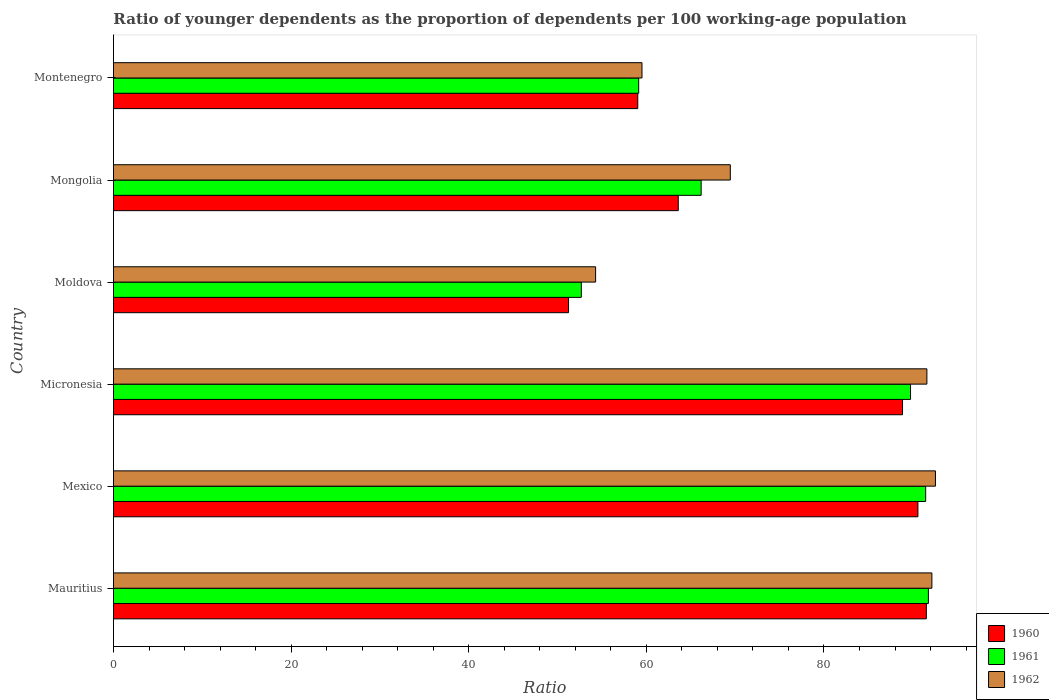How many groups of bars are there?
Give a very brief answer. 6. How many bars are there on the 4th tick from the top?
Offer a very short reply. 3. How many bars are there on the 3rd tick from the bottom?
Your answer should be very brief. 3. What is the label of the 2nd group of bars from the top?
Offer a terse response. Mongolia. In how many cases, is the number of bars for a given country not equal to the number of legend labels?
Offer a terse response. 0. What is the age dependency ratio(young) in 1960 in Montenegro?
Your response must be concise. 59.03. Across all countries, what is the maximum age dependency ratio(young) in 1962?
Provide a short and direct response. 92.55. Across all countries, what is the minimum age dependency ratio(young) in 1960?
Provide a succinct answer. 51.24. In which country was the age dependency ratio(young) in 1961 maximum?
Provide a succinct answer. Mauritius. In which country was the age dependency ratio(young) in 1961 minimum?
Offer a very short reply. Moldova. What is the total age dependency ratio(young) in 1960 in the graph?
Your response must be concise. 444.82. What is the difference between the age dependency ratio(young) in 1961 in Mongolia and that in Montenegro?
Your answer should be very brief. 7.03. What is the difference between the age dependency ratio(young) in 1962 in Mauritius and the age dependency ratio(young) in 1961 in Mexico?
Give a very brief answer. 0.7. What is the average age dependency ratio(young) in 1961 per country?
Your answer should be very brief. 75.16. What is the difference between the age dependency ratio(young) in 1961 and age dependency ratio(young) in 1960 in Mongolia?
Your answer should be very brief. 2.58. In how many countries, is the age dependency ratio(young) in 1962 greater than 24 ?
Offer a terse response. 6. What is the ratio of the age dependency ratio(young) in 1960 in Mauritius to that in Micronesia?
Your answer should be very brief. 1.03. Is the difference between the age dependency ratio(young) in 1961 in Mauritius and Montenegro greater than the difference between the age dependency ratio(young) in 1960 in Mauritius and Montenegro?
Make the answer very short. Yes. What is the difference between the highest and the second highest age dependency ratio(young) in 1960?
Keep it short and to the point. 0.95. What is the difference between the highest and the lowest age dependency ratio(young) in 1960?
Make the answer very short. 40.29. In how many countries, is the age dependency ratio(young) in 1961 greater than the average age dependency ratio(young) in 1961 taken over all countries?
Offer a very short reply. 3. Is the sum of the age dependency ratio(young) in 1960 in Mexico and Montenegro greater than the maximum age dependency ratio(young) in 1962 across all countries?
Offer a very short reply. Yes. What does the 2nd bar from the top in Micronesia represents?
Give a very brief answer. 1961. Is it the case that in every country, the sum of the age dependency ratio(young) in 1962 and age dependency ratio(young) in 1961 is greater than the age dependency ratio(young) in 1960?
Make the answer very short. Yes. Are all the bars in the graph horizontal?
Your answer should be very brief. Yes. What is the difference between two consecutive major ticks on the X-axis?
Offer a very short reply. 20. Are the values on the major ticks of X-axis written in scientific E-notation?
Your answer should be compact. No. Does the graph contain any zero values?
Your answer should be compact. No. How are the legend labels stacked?
Your response must be concise. Vertical. What is the title of the graph?
Keep it short and to the point. Ratio of younger dependents as the proportion of dependents per 100 working-age population. Does "1979" appear as one of the legend labels in the graph?
Give a very brief answer. No. What is the label or title of the X-axis?
Ensure brevity in your answer.  Ratio. What is the Ratio in 1960 in Mauritius?
Provide a short and direct response. 91.53. What is the Ratio in 1961 in Mauritius?
Make the answer very short. 91.76. What is the Ratio of 1962 in Mauritius?
Provide a short and direct response. 92.15. What is the Ratio in 1960 in Mexico?
Give a very brief answer. 90.58. What is the Ratio in 1961 in Mexico?
Offer a terse response. 91.45. What is the Ratio of 1962 in Mexico?
Your response must be concise. 92.55. What is the Ratio in 1960 in Micronesia?
Provide a succinct answer. 88.85. What is the Ratio of 1961 in Micronesia?
Your answer should be compact. 89.75. What is the Ratio in 1962 in Micronesia?
Offer a terse response. 91.59. What is the Ratio of 1960 in Moldova?
Give a very brief answer. 51.24. What is the Ratio in 1961 in Moldova?
Give a very brief answer. 52.68. What is the Ratio in 1962 in Moldova?
Provide a succinct answer. 54.29. What is the Ratio in 1960 in Mongolia?
Provide a succinct answer. 63.59. What is the Ratio of 1961 in Mongolia?
Your response must be concise. 66.17. What is the Ratio of 1962 in Mongolia?
Make the answer very short. 69.46. What is the Ratio of 1960 in Montenegro?
Provide a short and direct response. 59.03. What is the Ratio in 1961 in Montenegro?
Keep it short and to the point. 59.14. What is the Ratio in 1962 in Montenegro?
Make the answer very short. 59.51. Across all countries, what is the maximum Ratio in 1960?
Provide a succinct answer. 91.53. Across all countries, what is the maximum Ratio in 1961?
Provide a short and direct response. 91.76. Across all countries, what is the maximum Ratio of 1962?
Your answer should be compact. 92.55. Across all countries, what is the minimum Ratio of 1960?
Provide a succinct answer. 51.24. Across all countries, what is the minimum Ratio in 1961?
Ensure brevity in your answer.  52.68. Across all countries, what is the minimum Ratio in 1962?
Offer a very short reply. 54.29. What is the total Ratio of 1960 in the graph?
Give a very brief answer. 444.82. What is the total Ratio in 1961 in the graph?
Offer a very short reply. 450.94. What is the total Ratio in 1962 in the graph?
Your answer should be very brief. 459.55. What is the difference between the Ratio of 1960 in Mauritius and that in Mexico?
Your answer should be very brief. 0.95. What is the difference between the Ratio of 1961 in Mauritius and that in Mexico?
Give a very brief answer. 0.31. What is the difference between the Ratio of 1962 in Mauritius and that in Mexico?
Make the answer very short. -0.4. What is the difference between the Ratio in 1960 in Mauritius and that in Micronesia?
Your response must be concise. 2.68. What is the difference between the Ratio of 1961 in Mauritius and that in Micronesia?
Ensure brevity in your answer.  2.01. What is the difference between the Ratio in 1962 in Mauritius and that in Micronesia?
Ensure brevity in your answer.  0.56. What is the difference between the Ratio of 1960 in Mauritius and that in Moldova?
Ensure brevity in your answer.  40.29. What is the difference between the Ratio of 1961 in Mauritius and that in Moldova?
Give a very brief answer. 39.08. What is the difference between the Ratio in 1962 in Mauritius and that in Moldova?
Your response must be concise. 37.86. What is the difference between the Ratio in 1960 in Mauritius and that in Mongolia?
Provide a succinct answer. 27.93. What is the difference between the Ratio of 1961 in Mauritius and that in Mongolia?
Offer a terse response. 25.59. What is the difference between the Ratio in 1962 in Mauritius and that in Mongolia?
Offer a very short reply. 22.7. What is the difference between the Ratio in 1960 in Mauritius and that in Montenegro?
Offer a terse response. 32.49. What is the difference between the Ratio in 1961 in Mauritius and that in Montenegro?
Your answer should be very brief. 32.62. What is the difference between the Ratio of 1962 in Mauritius and that in Montenegro?
Your answer should be very brief. 32.64. What is the difference between the Ratio in 1960 in Mexico and that in Micronesia?
Provide a short and direct response. 1.73. What is the difference between the Ratio of 1961 in Mexico and that in Micronesia?
Make the answer very short. 1.7. What is the difference between the Ratio in 1962 in Mexico and that in Micronesia?
Ensure brevity in your answer.  0.97. What is the difference between the Ratio of 1960 in Mexico and that in Moldova?
Give a very brief answer. 39.34. What is the difference between the Ratio in 1961 in Mexico and that in Moldova?
Provide a short and direct response. 38.77. What is the difference between the Ratio of 1962 in Mexico and that in Moldova?
Offer a very short reply. 38.27. What is the difference between the Ratio of 1960 in Mexico and that in Mongolia?
Make the answer very short. 26.99. What is the difference between the Ratio of 1961 in Mexico and that in Mongolia?
Give a very brief answer. 25.28. What is the difference between the Ratio in 1962 in Mexico and that in Mongolia?
Ensure brevity in your answer.  23.1. What is the difference between the Ratio in 1960 in Mexico and that in Montenegro?
Provide a succinct answer. 31.55. What is the difference between the Ratio in 1961 in Mexico and that in Montenegro?
Offer a terse response. 32.31. What is the difference between the Ratio in 1962 in Mexico and that in Montenegro?
Provide a succinct answer. 33.04. What is the difference between the Ratio in 1960 in Micronesia and that in Moldova?
Keep it short and to the point. 37.61. What is the difference between the Ratio of 1961 in Micronesia and that in Moldova?
Provide a succinct answer. 37.07. What is the difference between the Ratio in 1962 in Micronesia and that in Moldova?
Make the answer very short. 37.3. What is the difference between the Ratio in 1960 in Micronesia and that in Mongolia?
Your answer should be compact. 25.25. What is the difference between the Ratio in 1961 in Micronesia and that in Mongolia?
Provide a succinct answer. 23.58. What is the difference between the Ratio in 1962 in Micronesia and that in Mongolia?
Give a very brief answer. 22.13. What is the difference between the Ratio in 1960 in Micronesia and that in Montenegro?
Offer a terse response. 29.81. What is the difference between the Ratio of 1961 in Micronesia and that in Montenegro?
Provide a succinct answer. 30.61. What is the difference between the Ratio in 1962 in Micronesia and that in Montenegro?
Your answer should be very brief. 32.08. What is the difference between the Ratio of 1960 in Moldova and that in Mongolia?
Offer a very short reply. -12.36. What is the difference between the Ratio in 1961 in Moldova and that in Mongolia?
Provide a short and direct response. -13.49. What is the difference between the Ratio in 1962 in Moldova and that in Mongolia?
Offer a terse response. -15.17. What is the difference between the Ratio of 1960 in Moldova and that in Montenegro?
Give a very brief answer. -7.79. What is the difference between the Ratio in 1961 in Moldova and that in Montenegro?
Your answer should be compact. -6.46. What is the difference between the Ratio in 1962 in Moldova and that in Montenegro?
Your answer should be very brief. -5.22. What is the difference between the Ratio in 1960 in Mongolia and that in Montenegro?
Ensure brevity in your answer.  4.56. What is the difference between the Ratio of 1961 in Mongolia and that in Montenegro?
Give a very brief answer. 7.03. What is the difference between the Ratio in 1962 in Mongolia and that in Montenegro?
Ensure brevity in your answer.  9.95. What is the difference between the Ratio in 1960 in Mauritius and the Ratio in 1961 in Mexico?
Your answer should be very brief. 0.08. What is the difference between the Ratio of 1960 in Mauritius and the Ratio of 1962 in Mexico?
Your response must be concise. -1.03. What is the difference between the Ratio of 1961 in Mauritius and the Ratio of 1962 in Mexico?
Offer a terse response. -0.8. What is the difference between the Ratio of 1960 in Mauritius and the Ratio of 1961 in Micronesia?
Keep it short and to the point. 1.78. What is the difference between the Ratio of 1960 in Mauritius and the Ratio of 1962 in Micronesia?
Give a very brief answer. -0.06. What is the difference between the Ratio in 1961 in Mauritius and the Ratio in 1962 in Micronesia?
Give a very brief answer. 0.17. What is the difference between the Ratio of 1960 in Mauritius and the Ratio of 1961 in Moldova?
Make the answer very short. 38.85. What is the difference between the Ratio in 1960 in Mauritius and the Ratio in 1962 in Moldova?
Your answer should be compact. 37.24. What is the difference between the Ratio of 1961 in Mauritius and the Ratio of 1962 in Moldova?
Offer a very short reply. 37.47. What is the difference between the Ratio in 1960 in Mauritius and the Ratio in 1961 in Mongolia?
Your answer should be very brief. 25.36. What is the difference between the Ratio in 1960 in Mauritius and the Ratio in 1962 in Mongolia?
Provide a succinct answer. 22.07. What is the difference between the Ratio of 1961 in Mauritius and the Ratio of 1962 in Mongolia?
Provide a succinct answer. 22.3. What is the difference between the Ratio in 1960 in Mauritius and the Ratio in 1961 in Montenegro?
Ensure brevity in your answer.  32.39. What is the difference between the Ratio of 1960 in Mauritius and the Ratio of 1962 in Montenegro?
Make the answer very short. 32.02. What is the difference between the Ratio of 1961 in Mauritius and the Ratio of 1962 in Montenegro?
Your answer should be compact. 32.25. What is the difference between the Ratio of 1960 in Mexico and the Ratio of 1961 in Micronesia?
Ensure brevity in your answer.  0.83. What is the difference between the Ratio of 1960 in Mexico and the Ratio of 1962 in Micronesia?
Give a very brief answer. -1.01. What is the difference between the Ratio of 1961 in Mexico and the Ratio of 1962 in Micronesia?
Keep it short and to the point. -0.14. What is the difference between the Ratio in 1960 in Mexico and the Ratio in 1961 in Moldova?
Your answer should be very brief. 37.9. What is the difference between the Ratio of 1960 in Mexico and the Ratio of 1962 in Moldova?
Your response must be concise. 36.29. What is the difference between the Ratio in 1961 in Mexico and the Ratio in 1962 in Moldova?
Make the answer very short. 37.16. What is the difference between the Ratio of 1960 in Mexico and the Ratio of 1961 in Mongolia?
Offer a very short reply. 24.41. What is the difference between the Ratio of 1960 in Mexico and the Ratio of 1962 in Mongolia?
Offer a very short reply. 21.12. What is the difference between the Ratio in 1961 in Mexico and the Ratio in 1962 in Mongolia?
Offer a very short reply. 22. What is the difference between the Ratio in 1960 in Mexico and the Ratio in 1961 in Montenegro?
Give a very brief answer. 31.44. What is the difference between the Ratio of 1960 in Mexico and the Ratio of 1962 in Montenegro?
Provide a short and direct response. 31.07. What is the difference between the Ratio in 1961 in Mexico and the Ratio in 1962 in Montenegro?
Provide a succinct answer. 31.94. What is the difference between the Ratio in 1960 in Micronesia and the Ratio in 1961 in Moldova?
Make the answer very short. 36.17. What is the difference between the Ratio of 1960 in Micronesia and the Ratio of 1962 in Moldova?
Offer a terse response. 34.56. What is the difference between the Ratio in 1961 in Micronesia and the Ratio in 1962 in Moldova?
Your answer should be compact. 35.46. What is the difference between the Ratio in 1960 in Micronesia and the Ratio in 1961 in Mongolia?
Your response must be concise. 22.68. What is the difference between the Ratio of 1960 in Micronesia and the Ratio of 1962 in Mongolia?
Offer a very short reply. 19.39. What is the difference between the Ratio in 1961 in Micronesia and the Ratio in 1962 in Mongolia?
Your answer should be very brief. 20.29. What is the difference between the Ratio in 1960 in Micronesia and the Ratio in 1961 in Montenegro?
Make the answer very short. 29.71. What is the difference between the Ratio of 1960 in Micronesia and the Ratio of 1962 in Montenegro?
Your answer should be compact. 29.34. What is the difference between the Ratio in 1961 in Micronesia and the Ratio in 1962 in Montenegro?
Provide a succinct answer. 30.24. What is the difference between the Ratio in 1960 in Moldova and the Ratio in 1961 in Mongolia?
Offer a terse response. -14.93. What is the difference between the Ratio in 1960 in Moldova and the Ratio in 1962 in Mongolia?
Provide a succinct answer. -18.22. What is the difference between the Ratio in 1961 in Moldova and the Ratio in 1962 in Mongolia?
Provide a succinct answer. -16.78. What is the difference between the Ratio in 1960 in Moldova and the Ratio in 1961 in Montenegro?
Provide a short and direct response. -7.9. What is the difference between the Ratio in 1960 in Moldova and the Ratio in 1962 in Montenegro?
Make the answer very short. -8.27. What is the difference between the Ratio of 1961 in Moldova and the Ratio of 1962 in Montenegro?
Ensure brevity in your answer.  -6.83. What is the difference between the Ratio of 1960 in Mongolia and the Ratio of 1961 in Montenegro?
Provide a short and direct response. 4.46. What is the difference between the Ratio in 1960 in Mongolia and the Ratio in 1962 in Montenegro?
Your answer should be compact. 4.08. What is the difference between the Ratio in 1961 in Mongolia and the Ratio in 1962 in Montenegro?
Offer a terse response. 6.66. What is the average Ratio of 1960 per country?
Give a very brief answer. 74.14. What is the average Ratio of 1961 per country?
Keep it short and to the point. 75.16. What is the average Ratio in 1962 per country?
Ensure brevity in your answer.  76.59. What is the difference between the Ratio of 1960 and Ratio of 1961 in Mauritius?
Make the answer very short. -0.23. What is the difference between the Ratio of 1960 and Ratio of 1962 in Mauritius?
Your response must be concise. -0.62. What is the difference between the Ratio in 1961 and Ratio in 1962 in Mauritius?
Keep it short and to the point. -0.39. What is the difference between the Ratio of 1960 and Ratio of 1961 in Mexico?
Offer a terse response. -0.87. What is the difference between the Ratio in 1960 and Ratio in 1962 in Mexico?
Give a very brief answer. -1.97. What is the difference between the Ratio in 1961 and Ratio in 1962 in Mexico?
Provide a short and direct response. -1.1. What is the difference between the Ratio in 1960 and Ratio in 1961 in Micronesia?
Your response must be concise. -0.9. What is the difference between the Ratio in 1960 and Ratio in 1962 in Micronesia?
Your response must be concise. -2.74. What is the difference between the Ratio in 1961 and Ratio in 1962 in Micronesia?
Ensure brevity in your answer.  -1.84. What is the difference between the Ratio of 1960 and Ratio of 1961 in Moldova?
Your answer should be very brief. -1.44. What is the difference between the Ratio of 1960 and Ratio of 1962 in Moldova?
Your response must be concise. -3.05. What is the difference between the Ratio in 1961 and Ratio in 1962 in Moldova?
Your answer should be compact. -1.61. What is the difference between the Ratio of 1960 and Ratio of 1961 in Mongolia?
Keep it short and to the point. -2.58. What is the difference between the Ratio of 1960 and Ratio of 1962 in Mongolia?
Your answer should be compact. -5.86. What is the difference between the Ratio in 1961 and Ratio in 1962 in Mongolia?
Your response must be concise. -3.28. What is the difference between the Ratio in 1960 and Ratio in 1961 in Montenegro?
Your answer should be compact. -0.1. What is the difference between the Ratio in 1960 and Ratio in 1962 in Montenegro?
Your answer should be compact. -0.48. What is the difference between the Ratio of 1961 and Ratio of 1962 in Montenegro?
Make the answer very short. -0.37. What is the ratio of the Ratio in 1960 in Mauritius to that in Mexico?
Make the answer very short. 1.01. What is the ratio of the Ratio in 1960 in Mauritius to that in Micronesia?
Keep it short and to the point. 1.03. What is the ratio of the Ratio of 1961 in Mauritius to that in Micronesia?
Offer a very short reply. 1.02. What is the ratio of the Ratio of 1962 in Mauritius to that in Micronesia?
Make the answer very short. 1.01. What is the ratio of the Ratio of 1960 in Mauritius to that in Moldova?
Ensure brevity in your answer.  1.79. What is the ratio of the Ratio of 1961 in Mauritius to that in Moldova?
Provide a short and direct response. 1.74. What is the ratio of the Ratio of 1962 in Mauritius to that in Moldova?
Provide a succinct answer. 1.7. What is the ratio of the Ratio of 1960 in Mauritius to that in Mongolia?
Provide a succinct answer. 1.44. What is the ratio of the Ratio of 1961 in Mauritius to that in Mongolia?
Your answer should be very brief. 1.39. What is the ratio of the Ratio in 1962 in Mauritius to that in Mongolia?
Provide a succinct answer. 1.33. What is the ratio of the Ratio in 1960 in Mauritius to that in Montenegro?
Provide a short and direct response. 1.55. What is the ratio of the Ratio of 1961 in Mauritius to that in Montenegro?
Ensure brevity in your answer.  1.55. What is the ratio of the Ratio in 1962 in Mauritius to that in Montenegro?
Offer a very short reply. 1.55. What is the ratio of the Ratio in 1960 in Mexico to that in Micronesia?
Offer a very short reply. 1.02. What is the ratio of the Ratio in 1961 in Mexico to that in Micronesia?
Your response must be concise. 1.02. What is the ratio of the Ratio in 1962 in Mexico to that in Micronesia?
Ensure brevity in your answer.  1.01. What is the ratio of the Ratio of 1960 in Mexico to that in Moldova?
Ensure brevity in your answer.  1.77. What is the ratio of the Ratio in 1961 in Mexico to that in Moldova?
Give a very brief answer. 1.74. What is the ratio of the Ratio in 1962 in Mexico to that in Moldova?
Offer a terse response. 1.7. What is the ratio of the Ratio of 1960 in Mexico to that in Mongolia?
Your answer should be compact. 1.42. What is the ratio of the Ratio of 1961 in Mexico to that in Mongolia?
Provide a succinct answer. 1.38. What is the ratio of the Ratio in 1962 in Mexico to that in Mongolia?
Your answer should be compact. 1.33. What is the ratio of the Ratio of 1960 in Mexico to that in Montenegro?
Provide a succinct answer. 1.53. What is the ratio of the Ratio in 1961 in Mexico to that in Montenegro?
Your answer should be very brief. 1.55. What is the ratio of the Ratio of 1962 in Mexico to that in Montenegro?
Keep it short and to the point. 1.56. What is the ratio of the Ratio in 1960 in Micronesia to that in Moldova?
Ensure brevity in your answer.  1.73. What is the ratio of the Ratio of 1961 in Micronesia to that in Moldova?
Offer a terse response. 1.7. What is the ratio of the Ratio in 1962 in Micronesia to that in Moldova?
Keep it short and to the point. 1.69. What is the ratio of the Ratio in 1960 in Micronesia to that in Mongolia?
Keep it short and to the point. 1.4. What is the ratio of the Ratio of 1961 in Micronesia to that in Mongolia?
Ensure brevity in your answer.  1.36. What is the ratio of the Ratio of 1962 in Micronesia to that in Mongolia?
Make the answer very short. 1.32. What is the ratio of the Ratio in 1960 in Micronesia to that in Montenegro?
Provide a short and direct response. 1.5. What is the ratio of the Ratio in 1961 in Micronesia to that in Montenegro?
Your answer should be compact. 1.52. What is the ratio of the Ratio in 1962 in Micronesia to that in Montenegro?
Keep it short and to the point. 1.54. What is the ratio of the Ratio in 1960 in Moldova to that in Mongolia?
Provide a succinct answer. 0.81. What is the ratio of the Ratio in 1961 in Moldova to that in Mongolia?
Your response must be concise. 0.8. What is the ratio of the Ratio of 1962 in Moldova to that in Mongolia?
Your answer should be very brief. 0.78. What is the ratio of the Ratio in 1960 in Moldova to that in Montenegro?
Your response must be concise. 0.87. What is the ratio of the Ratio in 1961 in Moldova to that in Montenegro?
Offer a terse response. 0.89. What is the ratio of the Ratio in 1962 in Moldova to that in Montenegro?
Give a very brief answer. 0.91. What is the ratio of the Ratio in 1960 in Mongolia to that in Montenegro?
Ensure brevity in your answer.  1.08. What is the ratio of the Ratio in 1961 in Mongolia to that in Montenegro?
Make the answer very short. 1.12. What is the ratio of the Ratio of 1962 in Mongolia to that in Montenegro?
Provide a short and direct response. 1.17. What is the difference between the highest and the second highest Ratio of 1960?
Make the answer very short. 0.95. What is the difference between the highest and the second highest Ratio in 1961?
Make the answer very short. 0.31. What is the difference between the highest and the second highest Ratio in 1962?
Provide a succinct answer. 0.4. What is the difference between the highest and the lowest Ratio in 1960?
Make the answer very short. 40.29. What is the difference between the highest and the lowest Ratio in 1961?
Ensure brevity in your answer.  39.08. What is the difference between the highest and the lowest Ratio of 1962?
Keep it short and to the point. 38.27. 